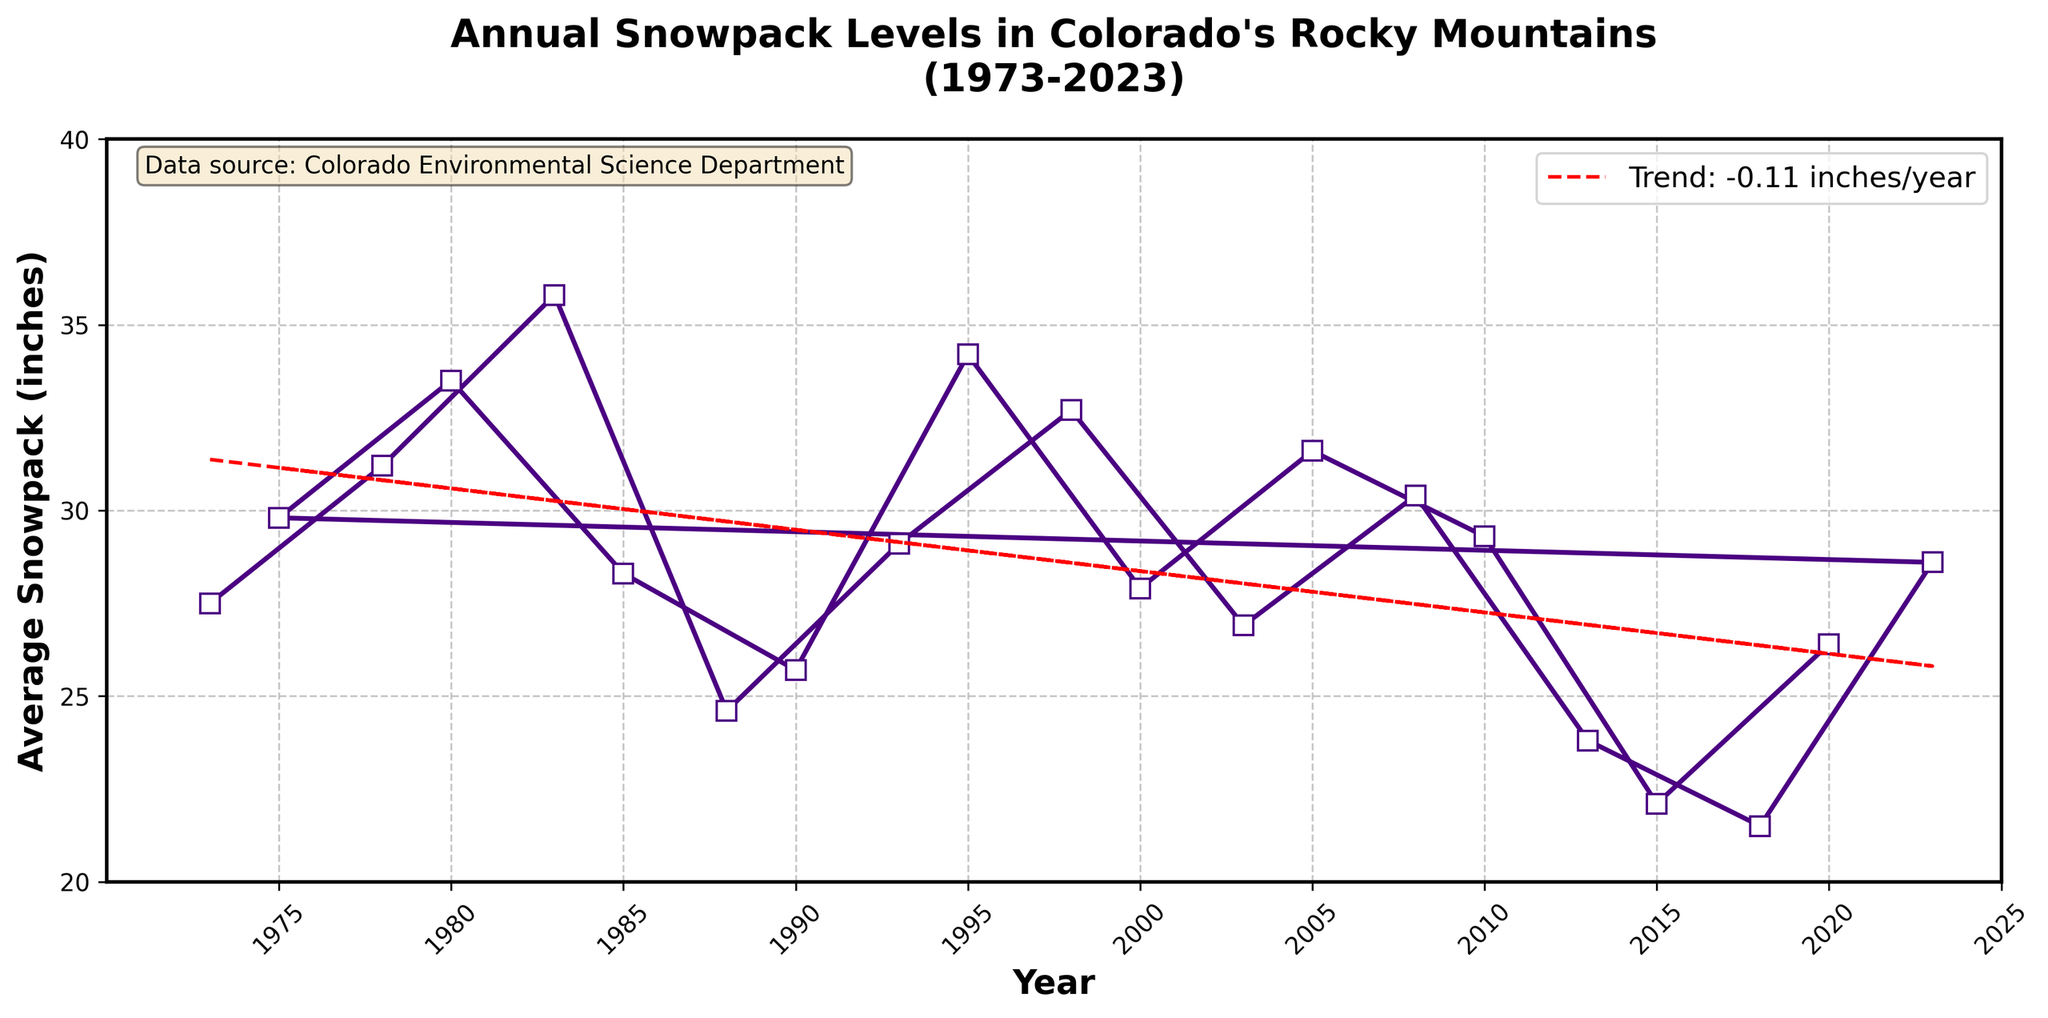What's the trend in snowpack levels over the years? The trend line in the figure shows a downward or negative slope, indicating that the average snowpack levels have been decreasing over the 50-year span. The red dashed trend line confirms this visual assessment.
Answer: Decreasing Which year had the highest recorded snowpack level, and what was that level? By visually examining the peaks in the plot, the highest data point occurs in 1983, with the highest marked snowpack level.
Answer: 1983, 35.8 inches How much did the snowpack level change between 1983 and 2018? To find the difference between the snowpack levels in these two years, subtract the value for 2018 from the value for 1983: 35.8 inches - 21.5 inches.
Answer: 14.3 inches Is there a year when the snowpack level is equal to the average snowpack level in 2008? By comparing the y-values, the average snowpack in 2008 is 30.4 inches. The figure shows approximately this level at multiple points, including 1978 and 2005.
Answer: 1978 and 2005 What are the color and style of the trend line in the figure? The trend line is a dashed line colored in red. This is indicated visually in the plot.
Answer: Red dashed Between which years did the snowpack level exhibit the most significant increase? Observe the plot and find the steepest upward slope between any two years. The steepest slope appears between 1988 and 1993, where the snowpack level increased from 24.6 inches to 29.1 inches.
Answer: 1988 to 1993 What is the average snowpack level from 2010 to 2020? The snowpack levels from 2010 to 2020 are 29.3, 22.1, 26.4, and 28.6 inches. Sum these values and divide by the number of entries: (29.3 + 22.1 + 26.4 + 28.6) / 4 = 26.6 inches.
Answer: 26.6 inches How has the snowpack level changed from 1973 to 1978? Compare the levels for these years: 1973 had a snowpack level of 27.5 inches, while 1978 had 31.2 inches. The change is 31.2 - 27.5.
Answer: Increased by 3.7 inches Among 1998, 2003, and 2008, which year had the lowest snowpack level? By visually comparing the y-values of these three data points: 1998 (32.7), 2003 (26.9), and 2008 (30.4), the lowest level is in 2003.
Answer: 2003 What is the visual appearance of the grid in the plot? The grid is indicated by dashed lines and is semi-transparent, facilitating the visibility of data points and trends.
Answer: Dashed and semi-transparent 